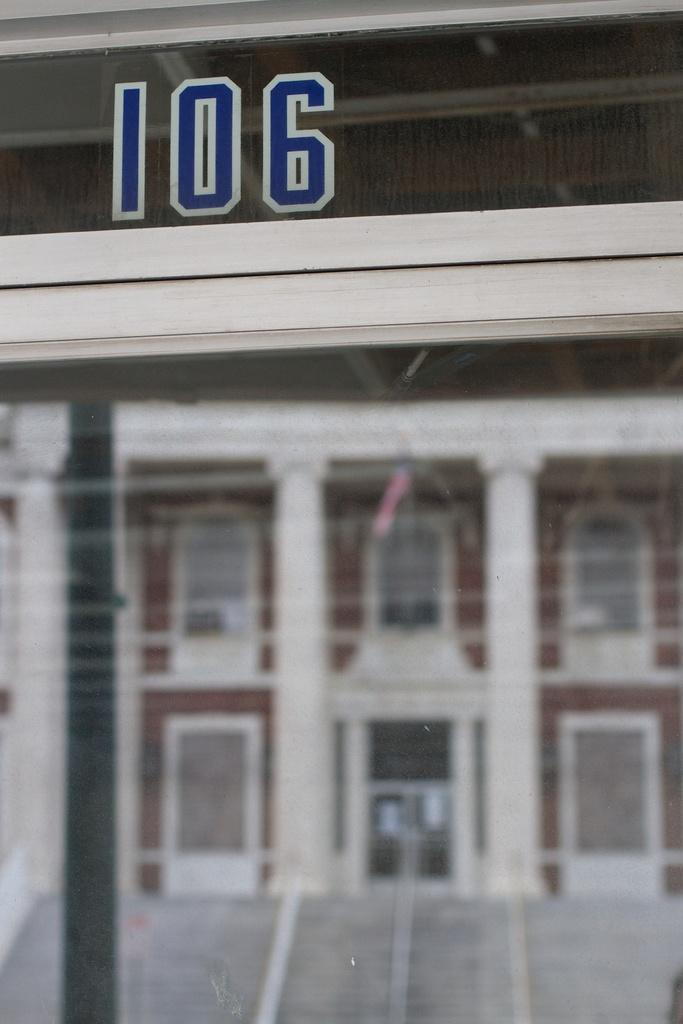<image>
Create a compact narrative representing the image presented. A red and white building is behind a sign saying 106 